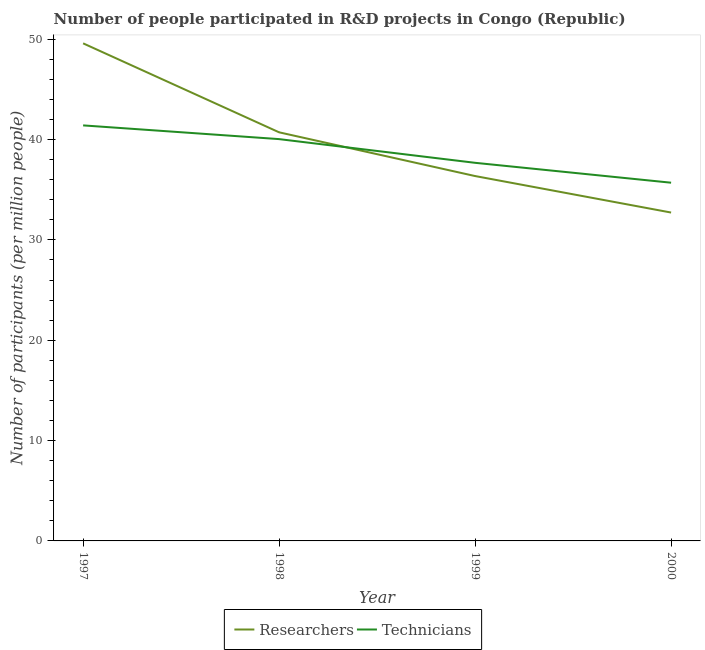Does the line corresponding to number of technicians intersect with the line corresponding to number of researchers?
Ensure brevity in your answer.  Yes. What is the number of researchers in 2000?
Your answer should be very brief. 32.72. Across all years, what is the maximum number of technicians?
Your answer should be very brief. 41.41. Across all years, what is the minimum number of technicians?
Your answer should be very brief. 35.7. In which year was the number of technicians maximum?
Provide a short and direct response. 1997. In which year was the number of researchers minimum?
Offer a very short reply. 2000. What is the total number of technicians in the graph?
Give a very brief answer. 154.84. What is the difference between the number of researchers in 1997 and that in 1999?
Your answer should be very brief. 13.23. What is the difference between the number of researchers in 1997 and the number of technicians in 2000?
Provide a succinct answer. 13.89. What is the average number of technicians per year?
Ensure brevity in your answer.  38.71. In the year 1997, what is the difference between the number of technicians and number of researchers?
Your answer should be compact. -8.18. What is the ratio of the number of technicians in 1997 to that in 1999?
Provide a short and direct response. 1.1. Is the number of technicians in 1998 less than that in 1999?
Make the answer very short. No. What is the difference between the highest and the second highest number of researchers?
Keep it short and to the point. 8.87. What is the difference between the highest and the lowest number of technicians?
Make the answer very short. 5.71. In how many years, is the number of technicians greater than the average number of technicians taken over all years?
Your answer should be compact. 2. Are the values on the major ticks of Y-axis written in scientific E-notation?
Give a very brief answer. No. How are the legend labels stacked?
Your answer should be compact. Horizontal. What is the title of the graph?
Provide a short and direct response. Number of people participated in R&D projects in Congo (Republic). What is the label or title of the Y-axis?
Your answer should be compact. Number of participants (per million people). What is the Number of participants (per million people) in Researchers in 1997?
Make the answer very short. 49.59. What is the Number of participants (per million people) in Technicians in 1997?
Offer a terse response. 41.41. What is the Number of participants (per million people) in Researchers in 1998?
Your answer should be compact. 40.72. What is the Number of participants (per million people) in Technicians in 1998?
Provide a succinct answer. 40.04. What is the Number of participants (per million people) in Researchers in 1999?
Provide a short and direct response. 36.36. What is the Number of participants (per million people) in Technicians in 1999?
Keep it short and to the point. 37.68. What is the Number of participants (per million people) in Researchers in 2000?
Provide a succinct answer. 32.72. What is the Number of participants (per million people) of Technicians in 2000?
Keep it short and to the point. 35.7. Across all years, what is the maximum Number of participants (per million people) in Researchers?
Offer a very short reply. 49.59. Across all years, what is the maximum Number of participants (per million people) in Technicians?
Provide a short and direct response. 41.41. Across all years, what is the minimum Number of participants (per million people) of Researchers?
Make the answer very short. 32.72. Across all years, what is the minimum Number of participants (per million people) in Technicians?
Give a very brief answer. 35.7. What is the total Number of participants (per million people) in Researchers in the graph?
Keep it short and to the point. 159.4. What is the total Number of participants (per million people) of Technicians in the graph?
Give a very brief answer. 154.84. What is the difference between the Number of participants (per million people) of Researchers in 1997 and that in 1998?
Provide a short and direct response. 8.87. What is the difference between the Number of participants (per million people) in Technicians in 1997 and that in 1998?
Provide a succinct answer. 1.37. What is the difference between the Number of participants (per million people) in Researchers in 1997 and that in 1999?
Offer a terse response. 13.23. What is the difference between the Number of participants (per million people) in Technicians in 1997 and that in 1999?
Ensure brevity in your answer.  3.73. What is the difference between the Number of participants (per million people) in Researchers in 1997 and that in 2000?
Your answer should be very brief. 16.86. What is the difference between the Number of participants (per million people) in Technicians in 1997 and that in 2000?
Keep it short and to the point. 5.71. What is the difference between the Number of participants (per million people) in Researchers in 1998 and that in 1999?
Offer a terse response. 4.36. What is the difference between the Number of participants (per million people) in Technicians in 1998 and that in 1999?
Keep it short and to the point. 2.36. What is the difference between the Number of participants (per million people) of Researchers in 1998 and that in 2000?
Your answer should be compact. 8. What is the difference between the Number of participants (per million people) in Technicians in 1998 and that in 2000?
Your answer should be very brief. 4.34. What is the difference between the Number of participants (per million people) of Researchers in 1999 and that in 2000?
Keep it short and to the point. 3.64. What is the difference between the Number of participants (per million people) of Technicians in 1999 and that in 2000?
Make the answer very short. 1.98. What is the difference between the Number of participants (per million people) in Researchers in 1997 and the Number of participants (per million people) in Technicians in 1998?
Your answer should be very brief. 9.54. What is the difference between the Number of participants (per million people) of Researchers in 1997 and the Number of participants (per million people) of Technicians in 1999?
Make the answer very short. 11.91. What is the difference between the Number of participants (per million people) in Researchers in 1997 and the Number of participants (per million people) in Technicians in 2000?
Make the answer very short. 13.89. What is the difference between the Number of participants (per million people) of Researchers in 1998 and the Number of participants (per million people) of Technicians in 1999?
Provide a short and direct response. 3.04. What is the difference between the Number of participants (per million people) in Researchers in 1998 and the Number of participants (per million people) in Technicians in 2000?
Provide a short and direct response. 5.02. What is the difference between the Number of participants (per million people) in Researchers in 1999 and the Number of participants (per million people) in Technicians in 2000?
Keep it short and to the point. 0.66. What is the average Number of participants (per million people) of Researchers per year?
Give a very brief answer. 39.85. What is the average Number of participants (per million people) of Technicians per year?
Offer a terse response. 38.71. In the year 1997, what is the difference between the Number of participants (per million people) in Researchers and Number of participants (per million people) in Technicians?
Offer a very short reply. 8.18. In the year 1998, what is the difference between the Number of participants (per million people) of Researchers and Number of participants (per million people) of Technicians?
Keep it short and to the point. 0.68. In the year 1999, what is the difference between the Number of participants (per million people) of Researchers and Number of participants (per million people) of Technicians?
Keep it short and to the point. -1.32. In the year 2000, what is the difference between the Number of participants (per million people) in Researchers and Number of participants (per million people) in Technicians?
Your answer should be compact. -2.98. What is the ratio of the Number of participants (per million people) of Researchers in 1997 to that in 1998?
Offer a very short reply. 1.22. What is the ratio of the Number of participants (per million people) of Technicians in 1997 to that in 1998?
Your answer should be very brief. 1.03. What is the ratio of the Number of participants (per million people) in Researchers in 1997 to that in 1999?
Offer a terse response. 1.36. What is the ratio of the Number of participants (per million people) of Technicians in 1997 to that in 1999?
Make the answer very short. 1.1. What is the ratio of the Number of participants (per million people) of Researchers in 1997 to that in 2000?
Provide a succinct answer. 1.52. What is the ratio of the Number of participants (per million people) of Technicians in 1997 to that in 2000?
Ensure brevity in your answer.  1.16. What is the ratio of the Number of participants (per million people) in Researchers in 1998 to that in 1999?
Offer a very short reply. 1.12. What is the ratio of the Number of participants (per million people) of Technicians in 1998 to that in 1999?
Offer a terse response. 1.06. What is the ratio of the Number of participants (per million people) of Researchers in 1998 to that in 2000?
Your answer should be very brief. 1.24. What is the ratio of the Number of participants (per million people) in Technicians in 1998 to that in 2000?
Provide a succinct answer. 1.12. What is the ratio of the Number of participants (per million people) of Researchers in 1999 to that in 2000?
Make the answer very short. 1.11. What is the ratio of the Number of participants (per million people) of Technicians in 1999 to that in 2000?
Your answer should be compact. 1.06. What is the difference between the highest and the second highest Number of participants (per million people) in Researchers?
Give a very brief answer. 8.87. What is the difference between the highest and the second highest Number of participants (per million people) in Technicians?
Your answer should be very brief. 1.37. What is the difference between the highest and the lowest Number of participants (per million people) of Researchers?
Your response must be concise. 16.86. What is the difference between the highest and the lowest Number of participants (per million people) in Technicians?
Your answer should be compact. 5.71. 